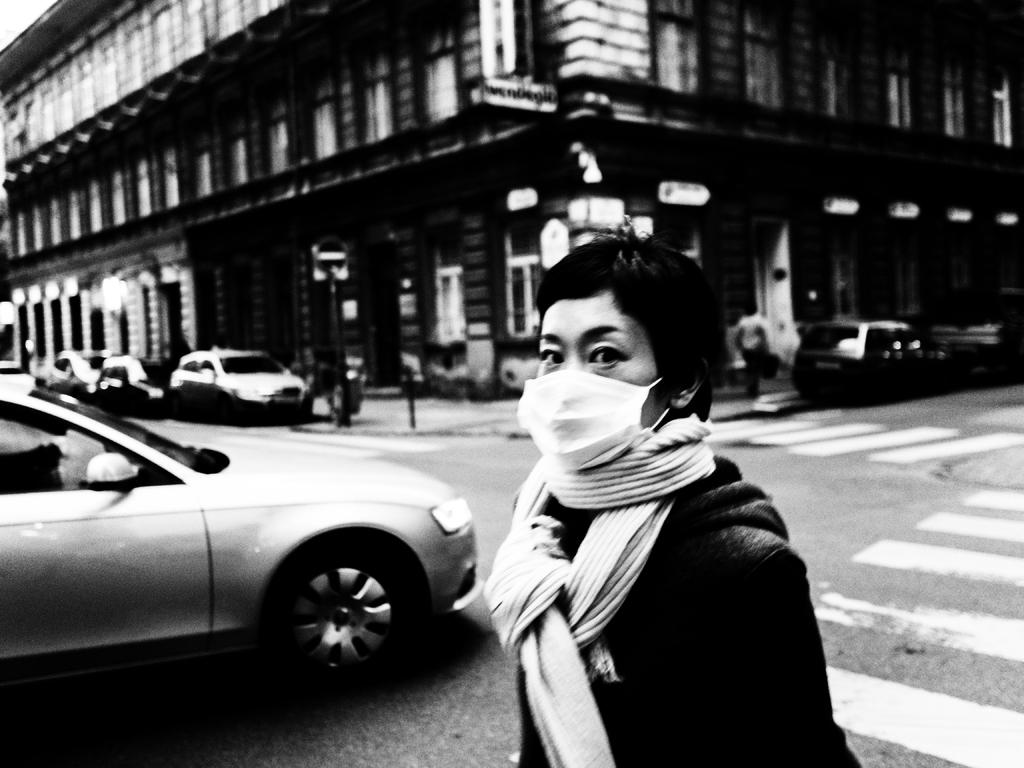What can be seen in the image involving multiple individuals? There is a group of people in the image. What else is present in the image besides the group of people? There are vehicles and a building in the image. Can you describe the woman in the image? The woman is present in the middle of the image and is wearing a mask. What is the color scheme of the image? The image is in black and white. What type of disease is the woman wearing a mask to protect against in the image? There is no indication of a specific disease in the image; the woman is simply wearing a mask. What type of skirt is the woman wearing in the image? The image is in black and white, and there is no mention of a skirt in the provided facts, so it cannot be determined from the image. 